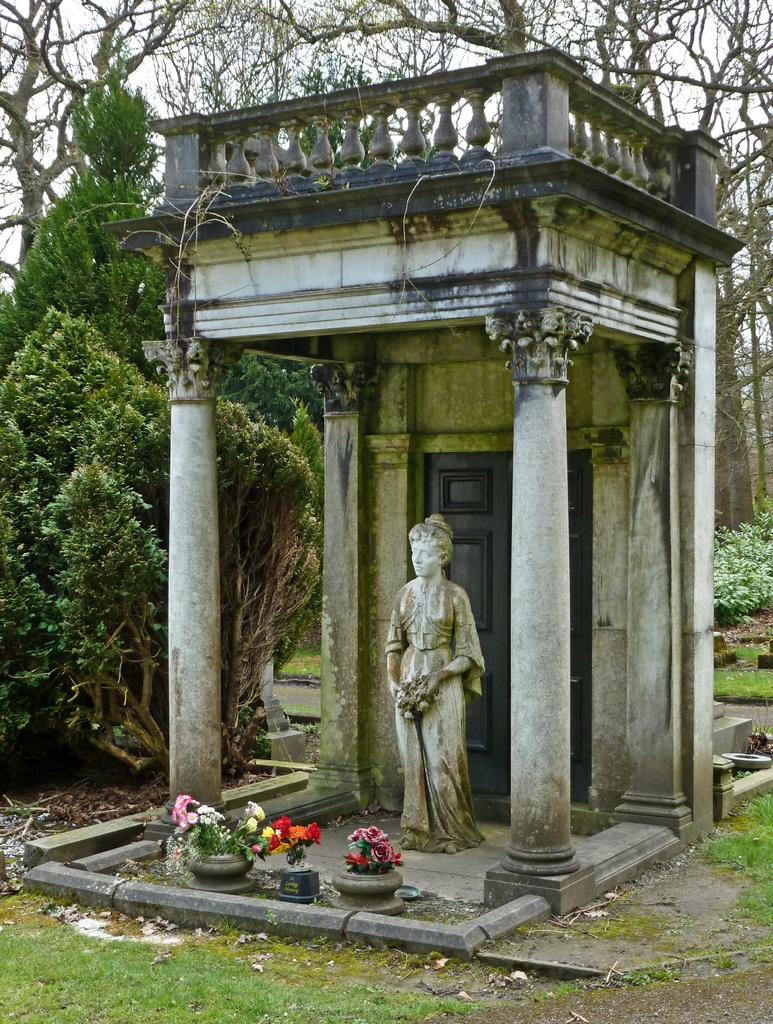What is the main subject of the image? There is a statue of a woman in the image. What can be seen on the left side of the image? There are trees on the left side of the image. What is located at the bottom of the image? There are flowers at the bottom of the image. What type of straw is the woman holding in the image? There is no straw present in the image; the statue is not holding anything. 